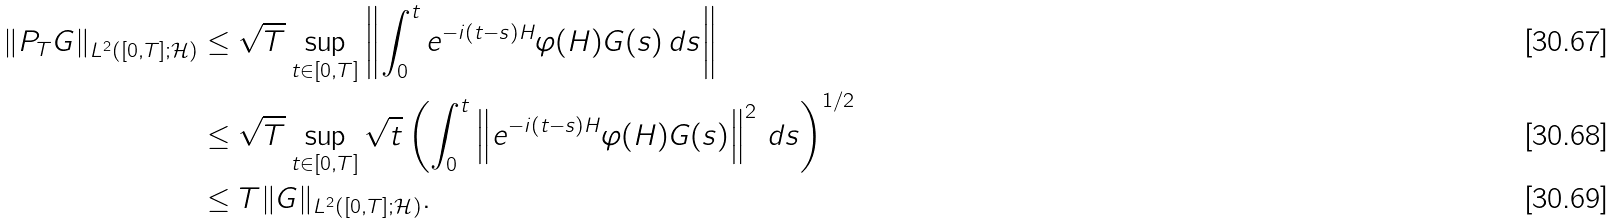Convert formula to latex. <formula><loc_0><loc_0><loc_500><loc_500>\| P _ { T } G \| _ { L ^ { 2 } ( [ 0 , T ] ; { \mathcal { H } } ) } & \leq \sqrt { T } \sup _ { t \in [ 0 , T ] } \left \| \int _ { 0 } ^ { t } e ^ { - i ( t - s ) H } \varphi ( H ) G ( s ) \, d s \right \| \\ & \leq \sqrt { T } \sup _ { t \in [ 0 , T ] } \sqrt { t } \left ( \int _ { 0 } ^ { t } \left \| e ^ { - i ( t - s ) H } \varphi ( H ) G ( s ) \right \| ^ { 2 } \, d s \right ) ^ { 1 / 2 } \\ & \leq T \| G \| _ { L ^ { 2 } ( [ 0 , T ] ; { \mathcal { H } } ) } .</formula> 